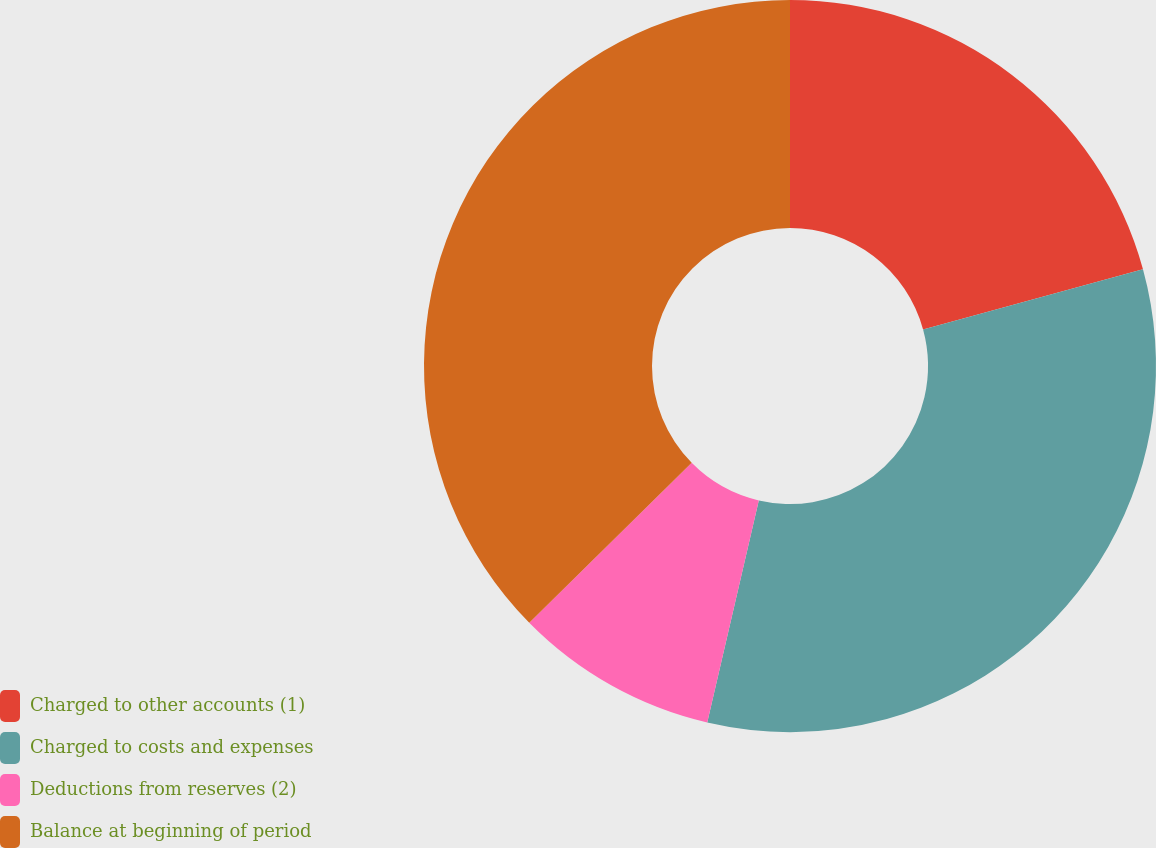Convert chart. <chart><loc_0><loc_0><loc_500><loc_500><pie_chart><fcel>Charged to other accounts (1)<fcel>Charged to costs and expenses<fcel>Deductions from reserves (2)<fcel>Balance at beginning of period<nl><fcel>20.74%<fcel>32.89%<fcel>8.99%<fcel>37.38%<nl></chart> 